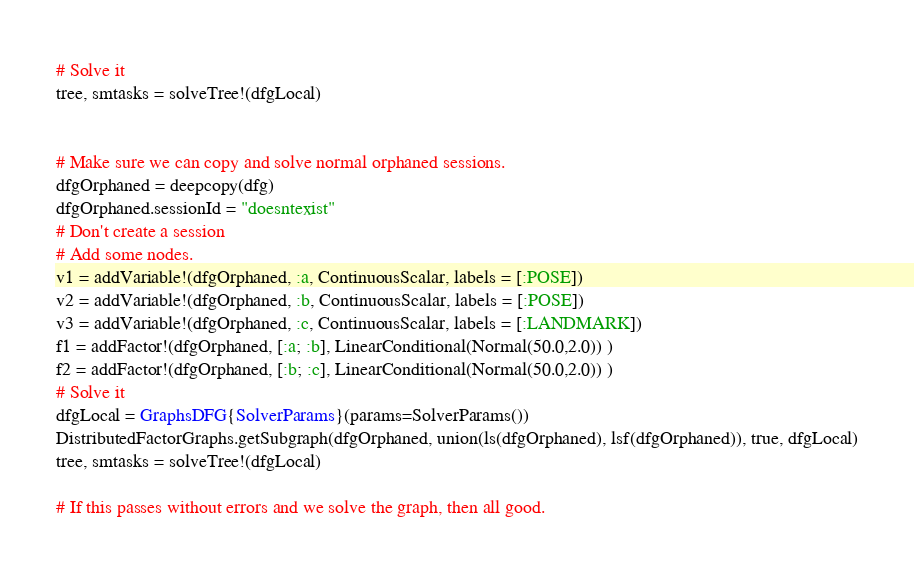<code> <loc_0><loc_0><loc_500><loc_500><_Julia_># Solve it
tree, smtasks = solveTree!(dfgLocal)


# Make sure we can copy and solve normal orphaned sessions.
dfgOrphaned = deepcopy(dfg)
dfgOrphaned.sessionId = "doesntexist"
# Don't create a session
# Add some nodes.
v1 = addVariable!(dfgOrphaned, :a, ContinuousScalar, labels = [:POSE])
v2 = addVariable!(dfgOrphaned, :b, ContinuousScalar, labels = [:POSE])
v3 = addVariable!(dfgOrphaned, :c, ContinuousScalar, labels = [:LANDMARK])
f1 = addFactor!(dfgOrphaned, [:a; :b], LinearConditional(Normal(50.0,2.0)) )
f2 = addFactor!(dfgOrphaned, [:b; :c], LinearConditional(Normal(50.0,2.0)) )
# Solve it
dfgLocal = GraphsDFG{SolverParams}(params=SolverParams())
DistributedFactorGraphs.getSubgraph(dfgOrphaned, union(ls(dfgOrphaned), lsf(dfgOrphaned)), true, dfgLocal)
tree, smtasks = solveTree!(dfgLocal)

# If this passes without errors and we solve the graph, then all good.
</code> 